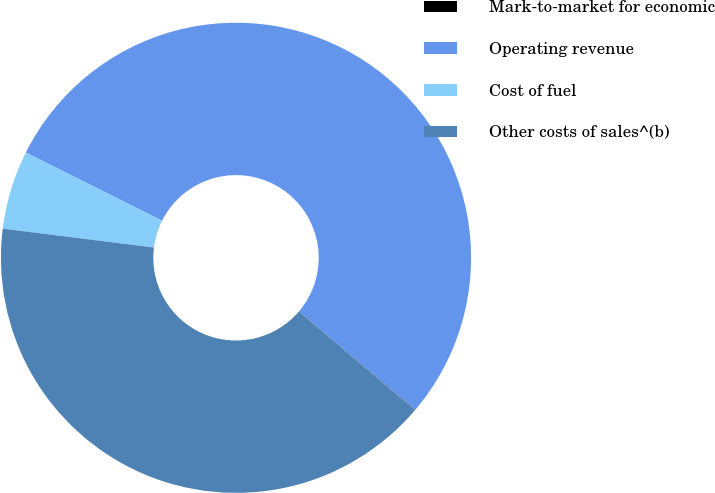Convert chart. <chart><loc_0><loc_0><loc_500><loc_500><pie_chart><fcel>Mark-to-market for economic<fcel>Operating revenue<fcel>Cost of fuel<fcel>Other costs of sales^(b)<nl><fcel>0.03%<fcel>53.81%<fcel>5.41%<fcel>40.75%<nl></chart> 